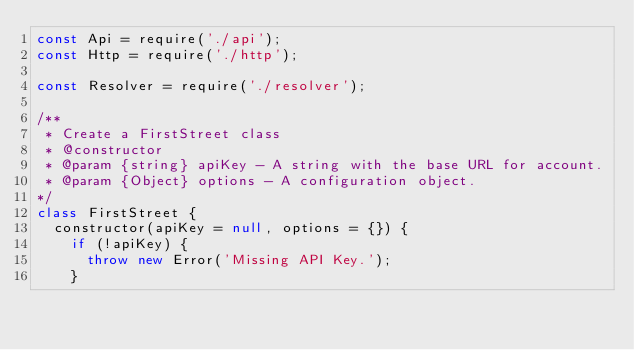Convert code to text. <code><loc_0><loc_0><loc_500><loc_500><_JavaScript_>const Api = require('./api');
const Http = require('./http');

const Resolver = require('./resolver');

/**
 * Create a FirstStreet class
 * @constructor
 * @param {string} apiKey - A string with the base URL for account.
 * @param {Object} options - A configuration object.
*/
class FirstStreet {
  constructor(apiKey = null, options = {}) {
    if (!apiKey) {
      throw new Error('Missing API Key.');
    }
</code> 